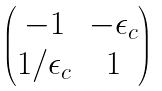<formula> <loc_0><loc_0><loc_500><loc_500>\begin{pmatrix} - 1 & - \epsilon _ { c } \\ 1 / \epsilon _ { c } & 1 \end{pmatrix}</formula> 